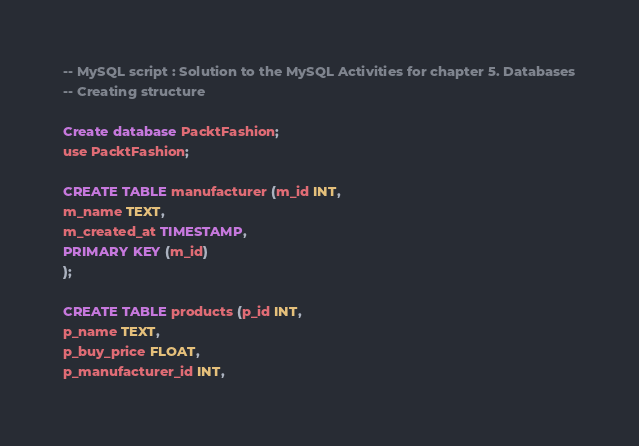<code> <loc_0><loc_0><loc_500><loc_500><_SQL_>
-- MySQL script : Solution to the MySQL Activities for chapter 5. Databases
-- Creating structure

Create database PacktFashion;
use PacktFashion;

CREATE TABLE manufacturer (m_id INT,
m_name TEXT,
m_created_at TIMESTAMP,
PRIMARY KEY (m_id)
);

CREATE TABLE products (p_id INT,
p_name TEXT,
p_buy_price FLOAT,
p_manufacturer_id INT,</code> 